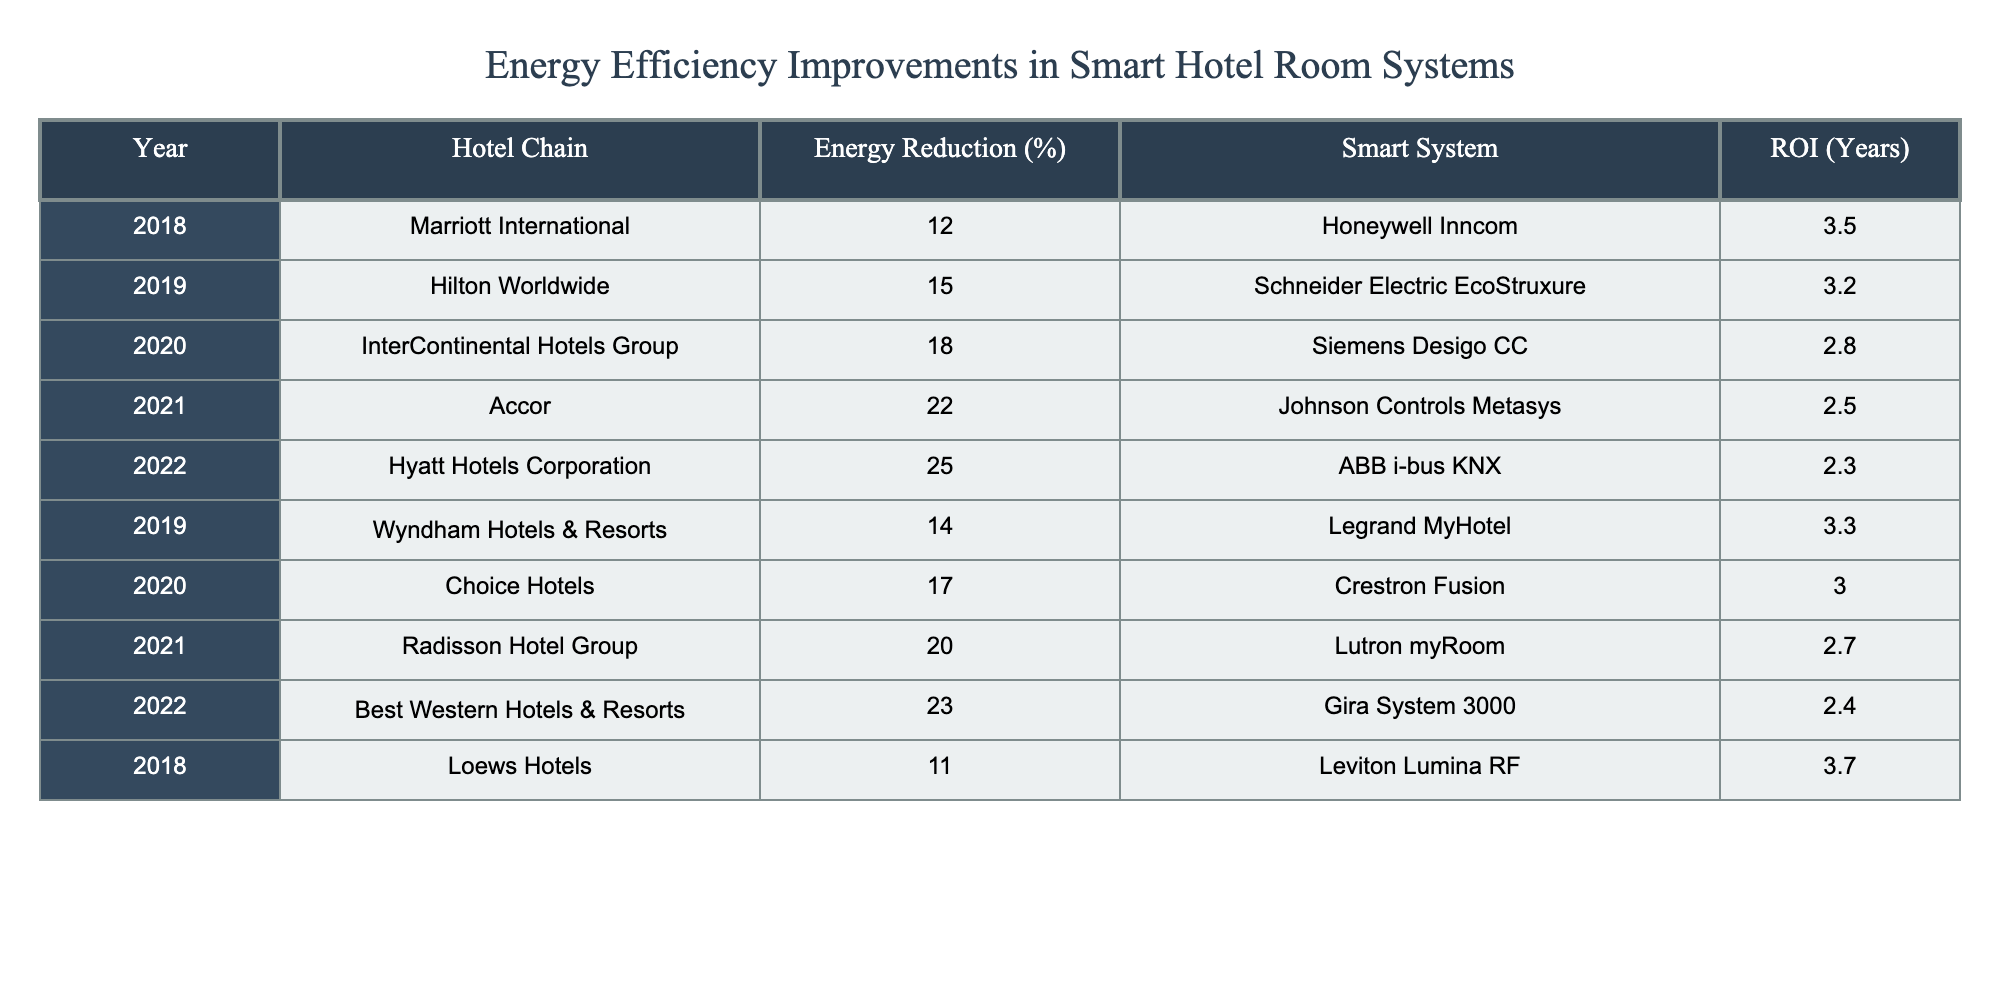What is the highest percentage of energy reduction achieved by a hotel chain in the past 5 years? The table shows that the highest percentage of energy reduction is 25%, achieved by Hyatt Hotels Corporation in 2022.
Answer: 25% Which hotel chain implemented the Honeywell Inncom smart system? According to the table, Marriott International implemented the Honeywell Inncom smart system in 2018.
Answer: Marriott International What is the average ROI for the smart systems listed in the table? To find the average ROI, sum the ROI values (3.5 + 3.2 + 2.8 + 2.5 + 2.3 + 3.3 + 3.0 + 2.7 + 2.4 + 3.7 = 28.0) and then divide by the number of systems (10). The average ROI is 28.0 / 10 = 2.8 years.
Answer: 2.8 years Did any hotel chain achieve an energy reduction greater than 20% in 2021? The table shows that Accor achieved a 22% energy reduction in 2021. Therefore, the statement is true.
Answer: Yes Which hotel chain had the lowest energy reduction percentage, and what was it? The table indicates that Loews Hotels had the lowest energy reduction percentage at 11% in 2018.
Answer: Loews Hotels, 11% Calculate the total energy reduction across all hotel chains in 2020. The energy reductions in 2020 are 18% (InterContinental Hotels Group) and 17% (Choice Hotels). Adding these gives 18 + 17 = 35%.
Answer: 35% Which smart system had the fastest ROI, and what was the duration? The table reveals that ABB i-bus KNX had the fastest ROI at 2.3 years in 2022.
Answer: ABB i-bus KNX, 2.3 years How does the energy reduction percentage of Hilton Worldwide in 2019 compare to that of Wyndham Hotels & Resorts in the same year? Hilton Worldwide had a 15% reduction while Wyndham Hotels & Resorts had a 14% reduction in 2019. Therefore, Hilton Worldwide had a higher percentage.
Answer: Hilton Worldwide had a higher percentage Which hotel chains had higher energy reductions than 20%? Referring to the table, the hotel chains with energy reductions greater than 20% are Accor (22%), Hyatt Hotels Corporation (25%), and Best Western Hotels & Resorts (23%) in 2021 and 2022.
Answer: Accor, Hyatt Hotels Corporation, Best Western Hotels & Resorts What was the trend in energy reduction percentages from 2018 to 2022 for the listed hotel chains? By examining the table, it is evident that energy reduction percentages increased over the years. 2018 had 12%, and it rose to 25% by 2022.
Answer: Increasing trend 